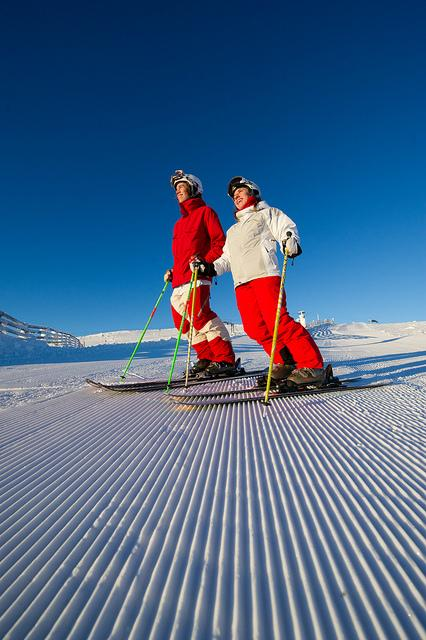How did these grooves get set in snow? snow groomer 